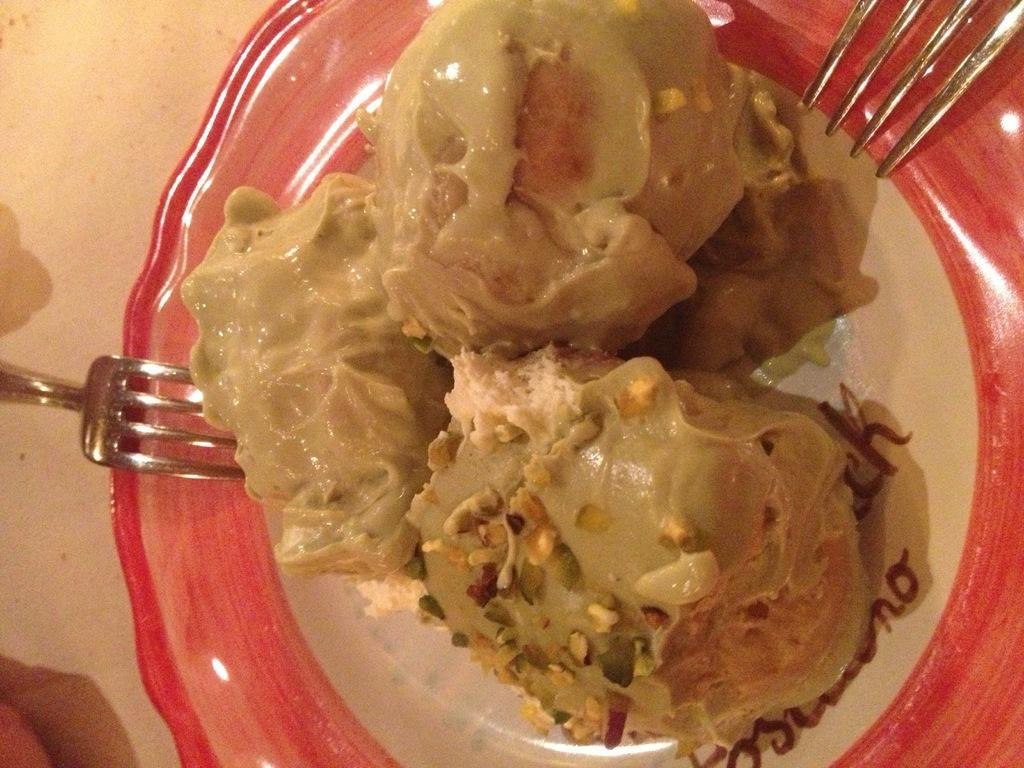Describe this image in one or two sentences. In the center of the image there is a table. On the table we can see forks, plate contains dessert are there. 